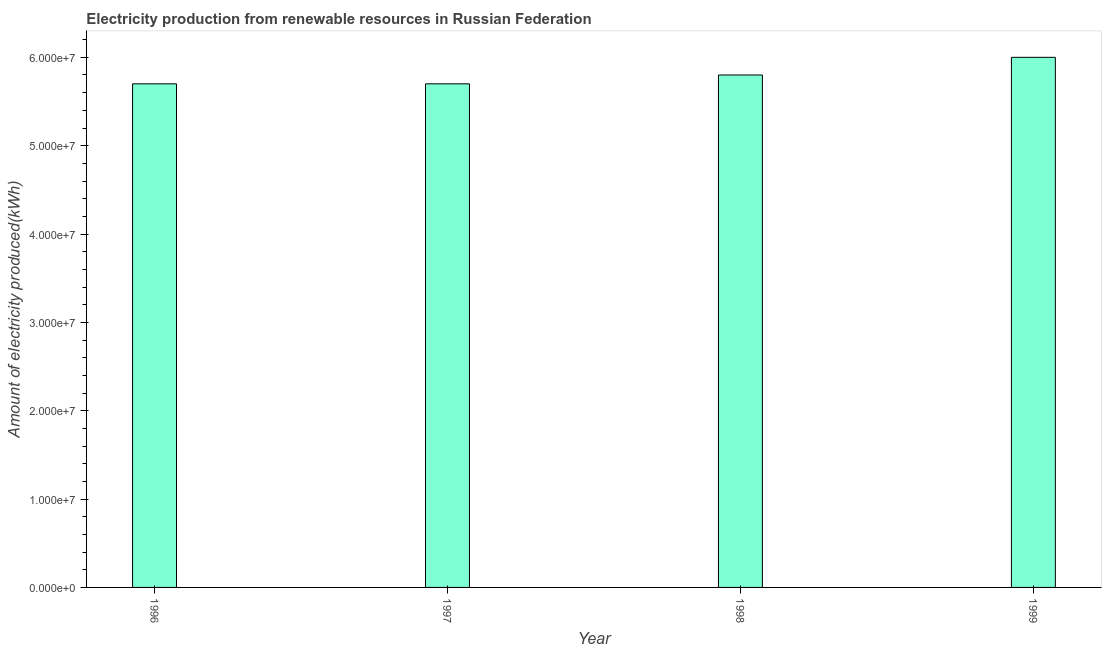Does the graph contain grids?
Provide a short and direct response. No. What is the title of the graph?
Offer a terse response. Electricity production from renewable resources in Russian Federation. What is the label or title of the Y-axis?
Keep it short and to the point. Amount of electricity produced(kWh). What is the amount of electricity produced in 1999?
Make the answer very short. 6.00e+07. Across all years, what is the maximum amount of electricity produced?
Make the answer very short. 6.00e+07. Across all years, what is the minimum amount of electricity produced?
Provide a succinct answer. 5.70e+07. What is the sum of the amount of electricity produced?
Offer a very short reply. 2.32e+08. What is the average amount of electricity produced per year?
Your response must be concise. 5.80e+07. What is the median amount of electricity produced?
Offer a very short reply. 5.75e+07. In how many years, is the amount of electricity produced greater than 20000000 kWh?
Your answer should be very brief. 4. Is the amount of electricity produced in 1998 less than that in 1999?
Provide a succinct answer. Yes. Is the difference between the amount of electricity produced in 1997 and 1999 greater than the difference between any two years?
Offer a terse response. Yes. What is the difference between the highest and the lowest amount of electricity produced?
Your response must be concise. 3.00e+06. In how many years, is the amount of electricity produced greater than the average amount of electricity produced taken over all years?
Offer a very short reply. 1. How many years are there in the graph?
Give a very brief answer. 4. What is the difference between two consecutive major ticks on the Y-axis?
Offer a very short reply. 1.00e+07. What is the Amount of electricity produced(kWh) of 1996?
Provide a succinct answer. 5.70e+07. What is the Amount of electricity produced(kWh) of 1997?
Provide a short and direct response. 5.70e+07. What is the Amount of electricity produced(kWh) in 1998?
Make the answer very short. 5.80e+07. What is the Amount of electricity produced(kWh) in 1999?
Your answer should be very brief. 6.00e+07. What is the difference between the Amount of electricity produced(kWh) in 1996 and 1998?
Provide a succinct answer. -1.00e+06. What is the difference between the Amount of electricity produced(kWh) in 1996 and 1999?
Ensure brevity in your answer.  -3.00e+06. What is the difference between the Amount of electricity produced(kWh) in 1997 and 1998?
Your response must be concise. -1.00e+06. What is the ratio of the Amount of electricity produced(kWh) in 1996 to that in 1997?
Provide a short and direct response. 1. What is the ratio of the Amount of electricity produced(kWh) in 1996 to that in 1998?
Your response must be concise. 0.98. What is the ratio of the Amount of electricity produced(kWh) in 1996 to that in 1999?
Make the answer very short. 0.95. What is the ratio of the Amount of electricity produced(kWh) in 1997 to that in 1999?
Your answer should be very brief. 0.95. What is the ratio of the Amount of electricity produced(kWh) in 1998 to that in 1999?
Make the answer very short. 0.97. 